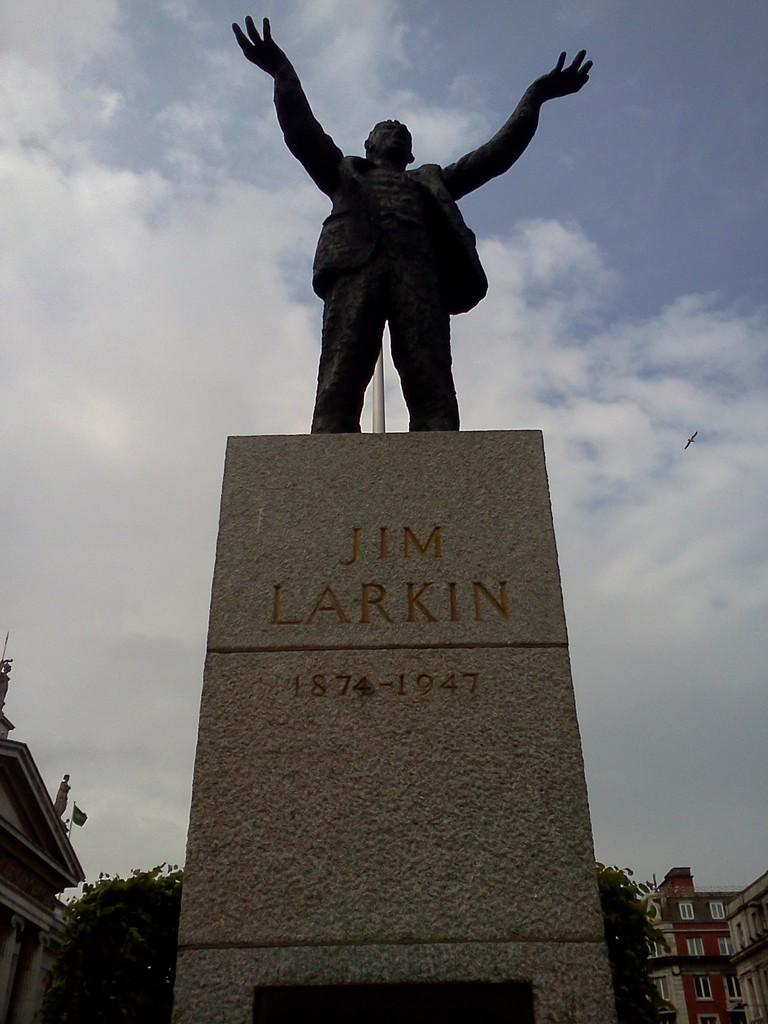What is the name of the sculpture in the image? The sculpture is named JIM LARKIN. What material is the sculpture made of? The sculpture is made of stone. What can be seen in the background of the image? There is a building in the background of the image. What type of vegetation is visible in the image? There is a tree visible in the image. What is the condition of the sky in the image? The sky is visible in the image, and it has heavy clouds. What type of furniture is visible in the image? There is no furniture visible in the image. Can you see a tiger in the image? No, there is no tiger present in the image. 